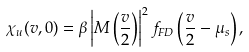Convert formula to latex. <formula><loc_0><loc_0><loc_500><loc_500>\chi _ { u } ( v , 0 ) = \beta \left | M \left ( \frac { v } { 2 } \right ) \right | ^ { 2 } f _ { F D } \left ( \frac { v } { 2 } - \mu _ { s } \right ) ,</formula> 